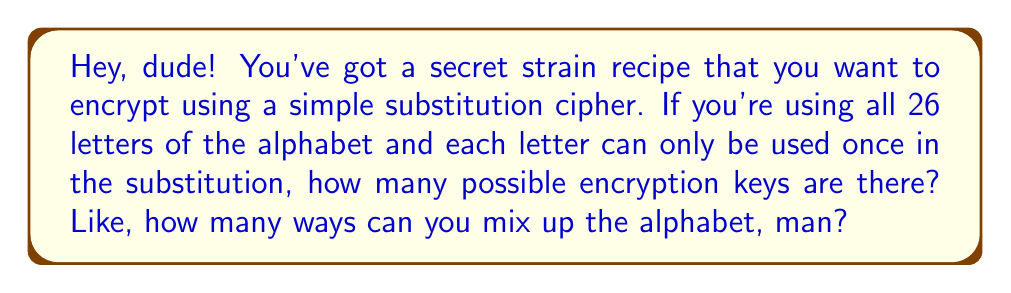Could you help me with this problem? Alright, let's break this down, bro:

1) In a simple substitution cipher, we're basically rearranging the alphabet. Each letter gets swapped with another letter, and no letter can be used twice.

2) This is like arranging all 26 letters in a new order. In math, we call this a permutation.

3) The number of ways to arrange n distinct objects is given by the factorial of n, written as n!

4) In this case, we have 26 letters, so we're looking at 26!

5) Let's calculate this step-by-step:

   $$26! = 26 \times 25 \times 24 \times 23 \times ... \times 3 \times 2 \times 1$$

6) This is a huge number, man! It's approximately:

   $$26! \approx 4.03 \times 10^{26}$$

7) To put this in perspective, that's more than the number of grains of sand on Earth!

So, there are 26! possible encryption keys for your secret strain recipe using a simple substitution cipher.
Answer: $26! \approx 4.03 \times 10^{26}$ 